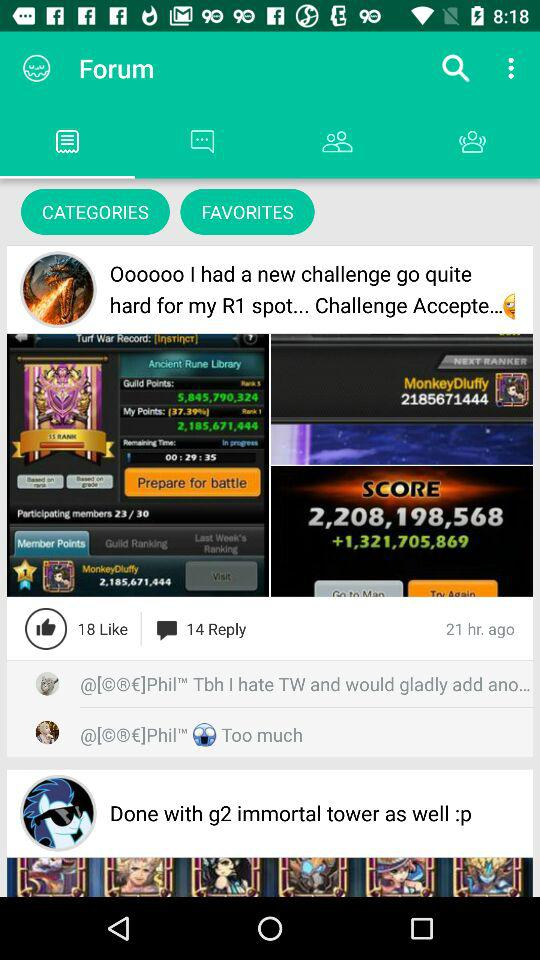How many replies in total are there? There are 14 replies in total. 